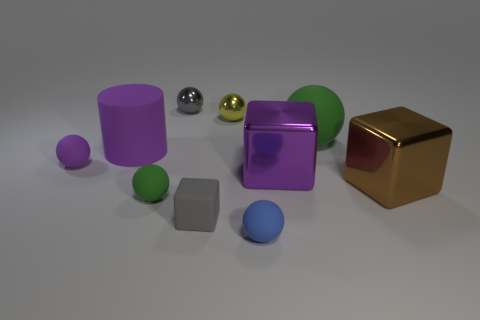What is the material of the other large thing that is the same shape as the brown metallic object?
Your answer should be compact. Metal. How many tiny spheres are both to the right of the gray shiny object and behind the big purple metal cube?
Your answer should be compact. 1. How many other purple things are the same shape as the tiny purple object?
Your answer should be very brief. 0. What is the color of the tiny matte ball to the right of the gray object that is to the right of the small gray shiny object?
Offer a terse response. Blue. Is the shape of the yellow metal thing the same as the tiny gray thing behind the large rubber cylinder?
Your answer should be compact. Yes. There is a purple object on the right side of the blue matte ball in front of the tiny gray thing behind the gray matte thing; what is its material?
Provide a short and direct response. Metal. Are there any purple matte things of the same size as the purple cube?
Keep it short and to the point. Yes. There is a block that is the same material as the small purple sphere; what is its size?
Offer a terse response. Small. What is the shape of the yellow metallic thing?
Keep it short and to the point. Sphere. Is the material of the purple ball the same as the big block right of the big rubber ball?
Your answer should be compact. No. 